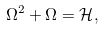Convert formula to latex. <formula><loc_0><loc_0><loc_500><loc_500>\Omega ^ { 2 } + \Omega = \mathcal { H } ,</formula> 